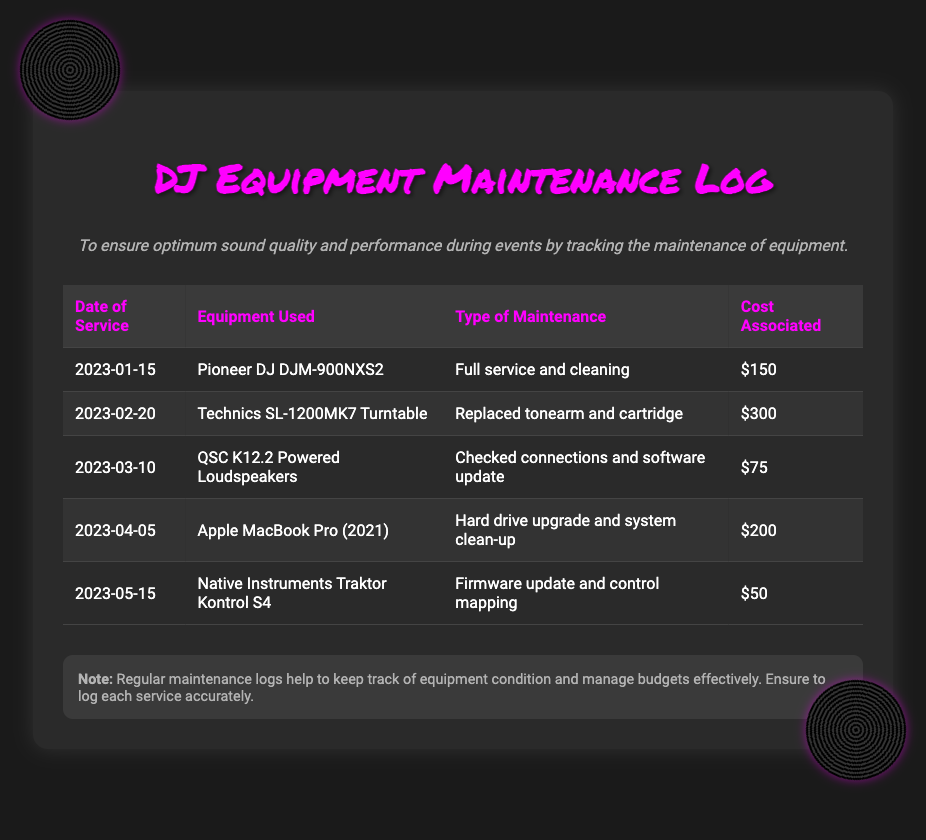What is the date of the first service logged? The date of the first service logged in the document is the earliest entry in the table, which is January 15, 2023.
Answer: January 15, 2023 What type of maintenance was performed on the Technics SL-1200MK7? The document details that the maintenance for the Technics SL-1200MK7 involved replacing the tonearm and cartridge.
Answer: Replaced tonearm and cartridge What was the cost of maintaining the QSC K12.2 Powered Loudspeakers? The cost associated with the service for the QSC K12.2 Powered Loudspeakers is found in the corresponding row and is $75.
Answer: $75 How many pieces of equipment had maintenance performed in total? The total number of equipment entries in the maintenance log can be obtained by counting the number of rows under the table header. There are five entries listed.
Answer: 5 Which equipment had a hard drive upgrade performed? The document specifies that the Apple MacBook Pro (2021) had a hard drive upgrade and system clean-up performed on it.
Answer: Apple MacBook Pro (2021) What was the total cost of maintenance performed on all equipment listed? The total cost can be calculated by adding all the costs associated with each maintenance entry: 150 + 300 + 75 + 200 + 50 = 775.
Answer: $775 What maintenance was performed on the Native Instruments Traktor Kontrol S4? The document mentions that the maintenance for the Native Instruments Traktor Kontrol S4 involved a firmware update and control mapping.
Answer: Firmware update and control mapping What is the main purpose of maintaining the equipment as described in the log? The purpose is outlined in the document as ensuring optimum sound quality and performance during events by keeping track of maintenance.
Answer: Optimum sound quality 